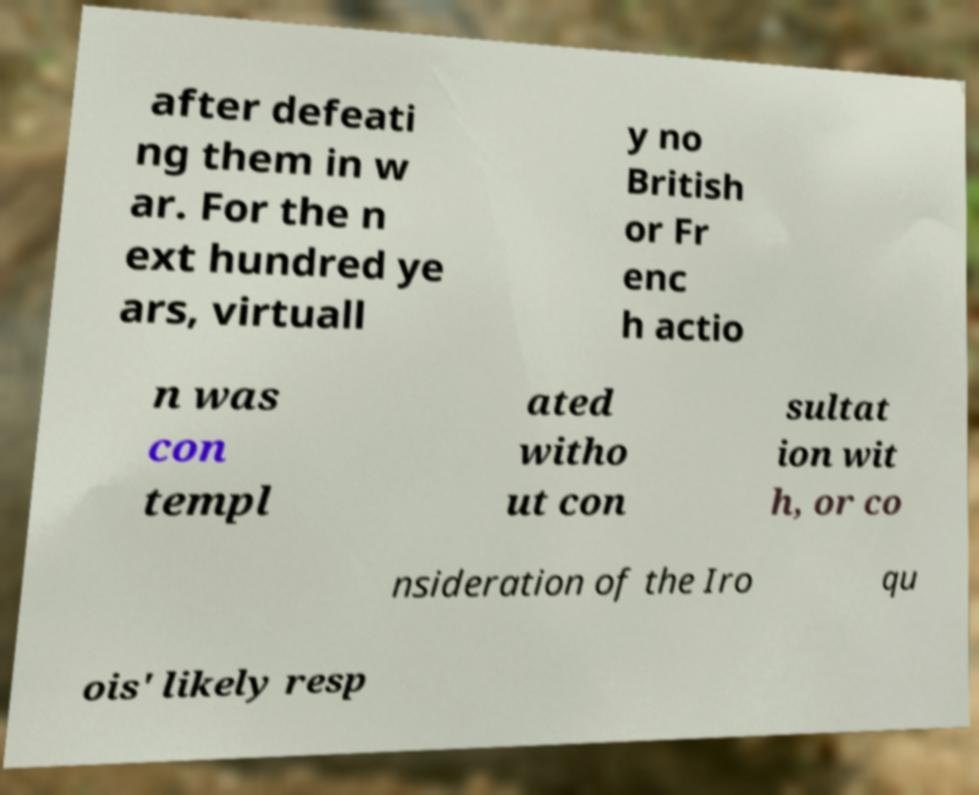Could you extract and type out the text from this image? after defeati ng them in w ar. For the n ext hundred ye ars, virtuall y no British or Fr enc h actio n was con templ ated witho ut con sultat ion wit h, or co nsideration of the Iro qu ois' likely resp 